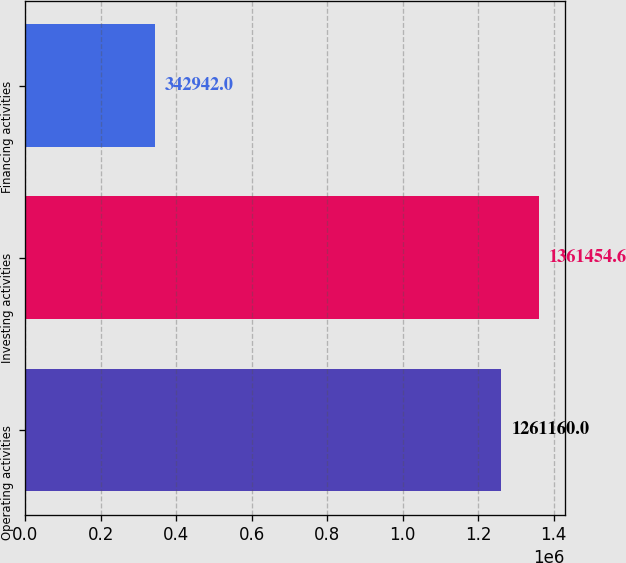Convert chart. <chart><loc_0><loc_0><loc_500><loc_500><bar_chart><fcel>Operating activities<fcel>Investing activities<fcel>Financing activities<nl><fcel>1.26116e+06<fcel>1.36145e+06<fcel>342942<nl></chart> 